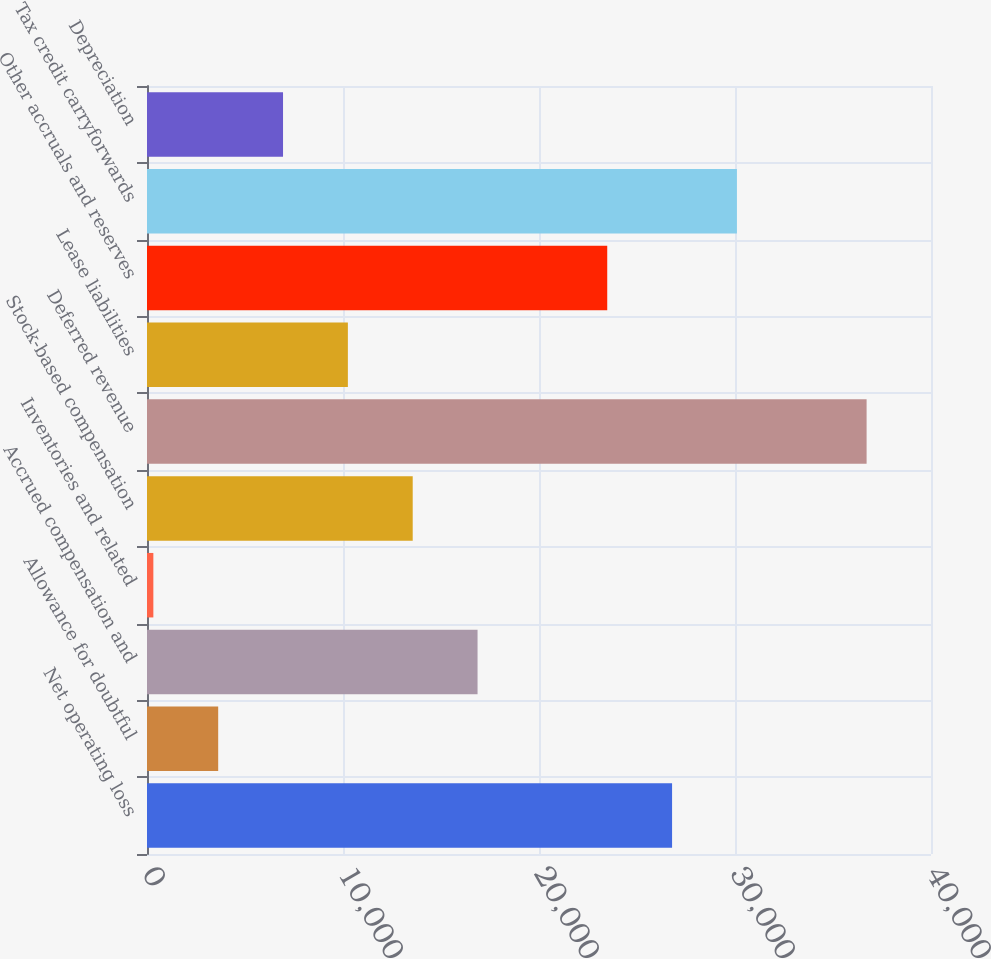Convert chart to OTSL. <chart><loc_0><loc_0><loc_500><loc_500><bar_chart><fcel>Net operating loss<fcel>Allowance for doubtful<fcel>Accrued compensation and<fcel>Inventories and related<fcel>Stock-based compensation<fcel>Deferred revenue<fcel>Lease liabilities<fcel>Other accruals and reserves<fcel>Tax credit carryforwards<fcel>Depreciation<nl><fcel>26789.6<fcel>3632.2<fcel>16865<fcel>324<fcel>13556.8<fcel>36714.2<fcel>10248.6<fcel>23481.4<fcel>30097.8<fcel>6940.4<nl></chart> 